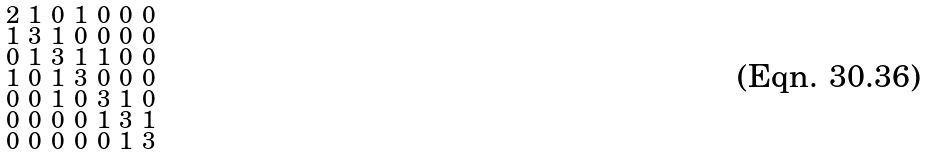<formula> <loc_0><loc_0><loc_500><loc_500>\begin{smallmatrix} 2 & 1 & 0 & 1 & 0 & 0 & 0 \\ 1 & 3 & 1 & 0 & 0 & 0 & 0 \\ 0 & 1 & 3 & 1 & 1 & 0 & 0 \\ 1 & 0 & 1 & 3 & 0 & 0 & 0 \\ 0 & 0 & 1 & 0 & 3 & 1 & 0 \\ 0 & 0 & 0 & 0 & 1 & 3 & 1 \\ 0 & 0 & 0 & 0 & 0 & 1 & 3 \end{smallmatrix}</formula> 